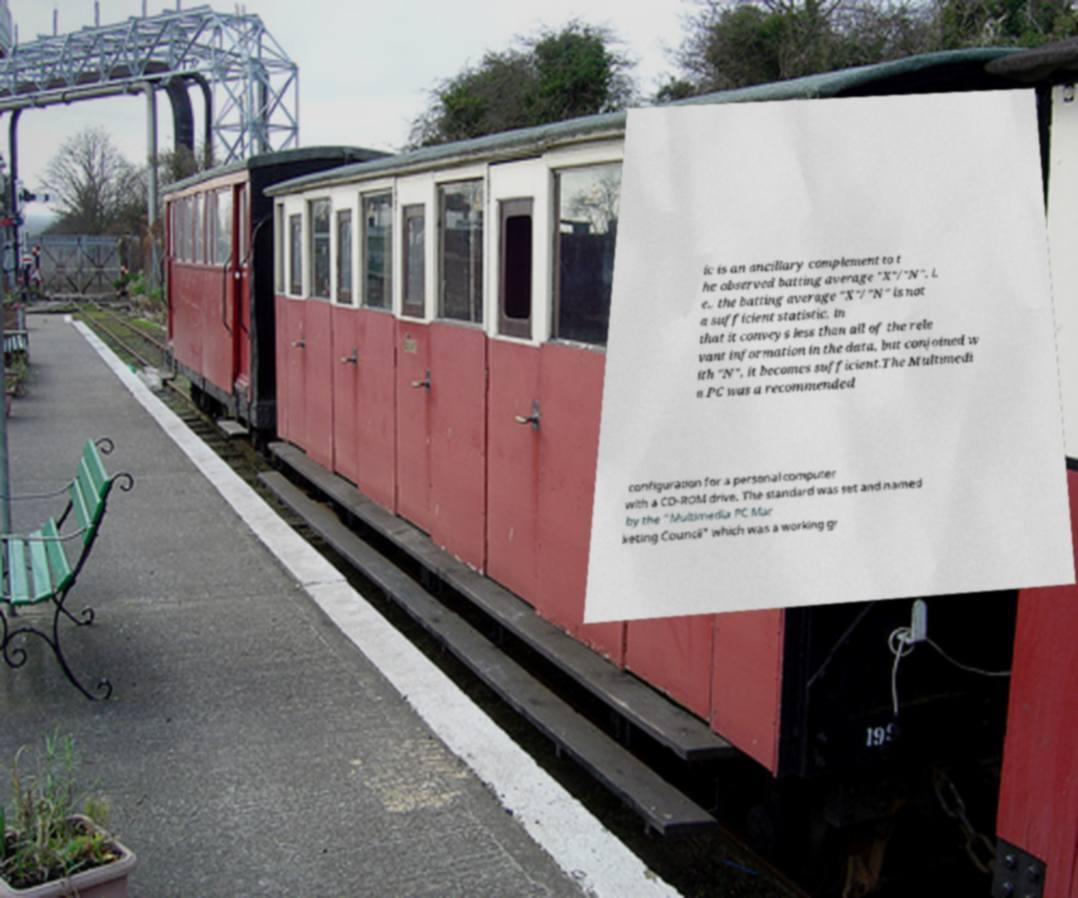I need the written content from this picture converted into text. Can you do that? ic is an ancillary complement to t he observed batting average "X"/"N", i. e., the batting average "X"/"N" is not a sufficient statistic, in that it conveys less than all of the rele vant information in the data, but conjoined w ith "N", it becomes sufficient.The Multimedi a PC was a recommended configuration for a personal computer with a CD-ROM drive. The standard was set and named by the "Multimedia PC Mar keting Council" which was a working gr 